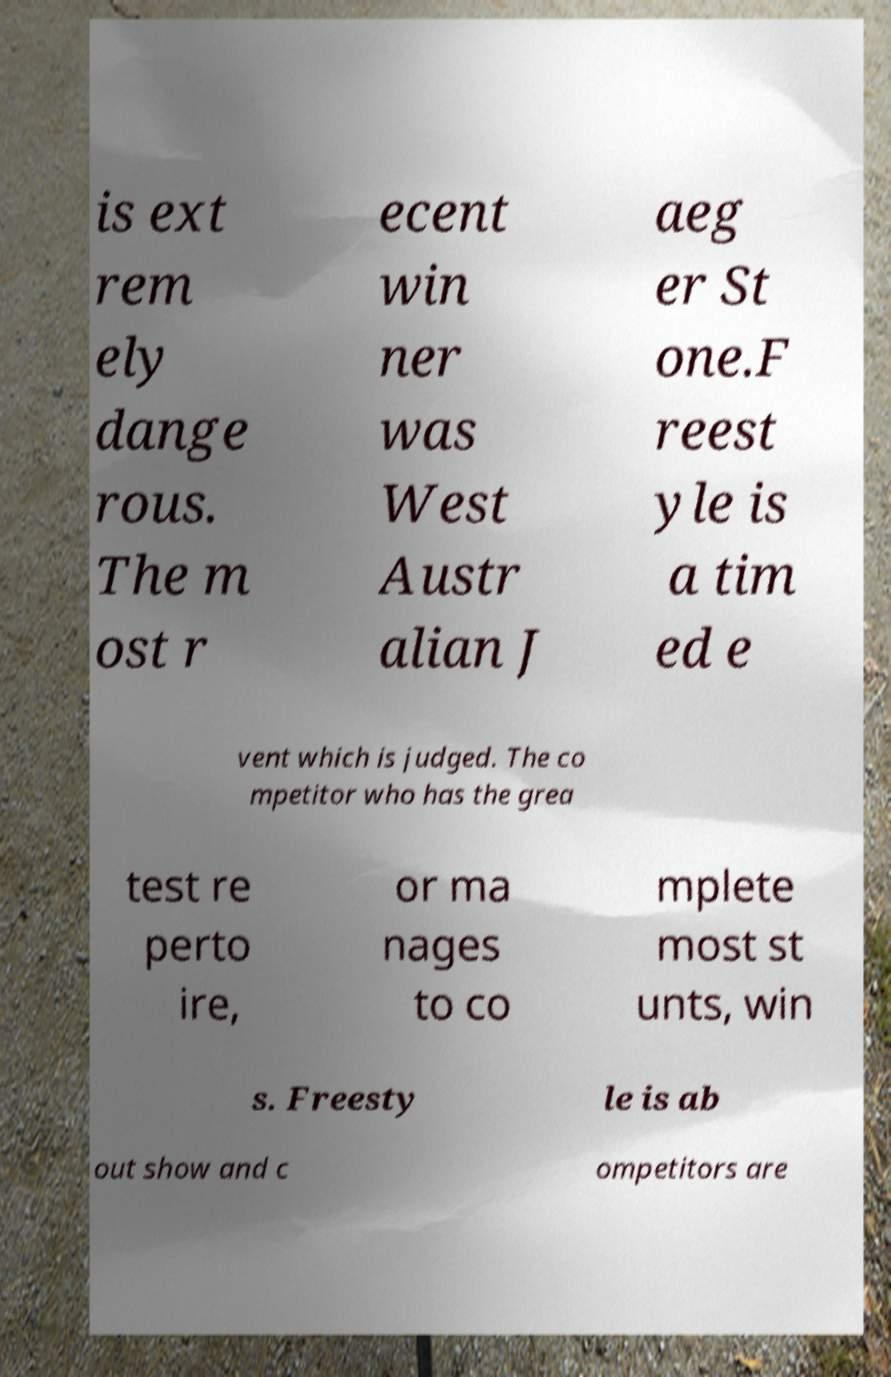There's text embedded in this image that I need extracted. Can you transcribe it verbatim? is ext rem ely dange rous. The m ost r ecent win ner was West Austr alian J aeg er St one.F reest yle is a tim ed e vent which is judged. The co mpetitor who has the grea test re perto ire, or ma nages to co mplete most st unts, win s. Freesty le is ab out show and c ompetitors are 